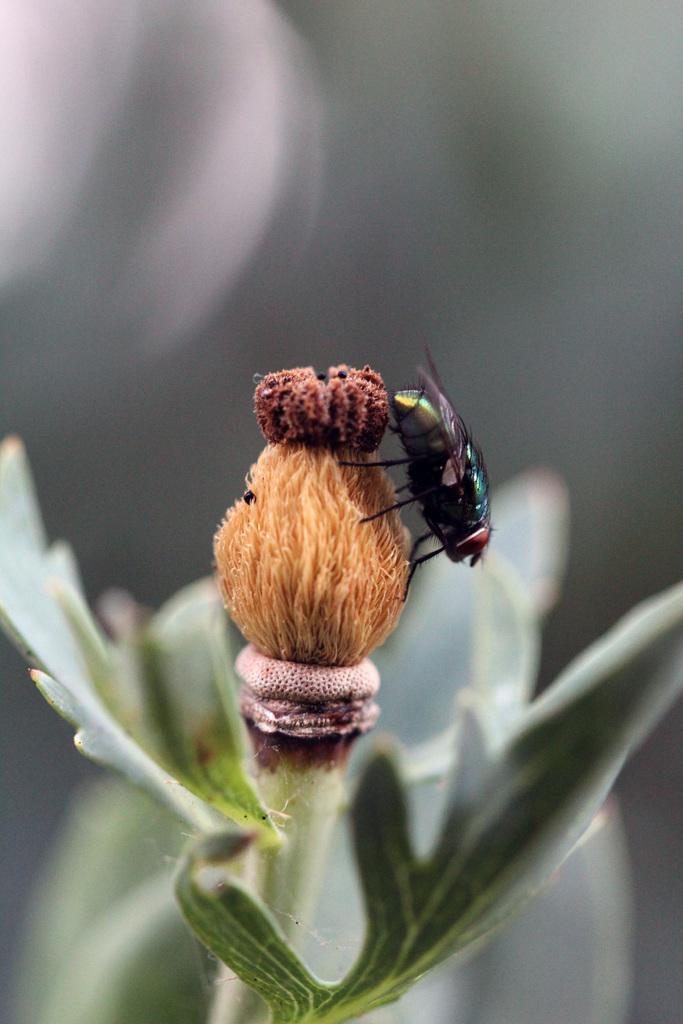What type of living organism is present in the image? There is a plant in the image. Can you describe any specific features of the plant? The plant has a leaf and a flower bud. Are there any other creatures visible in the image? Yes, there is a house fly in the image. What is a notable characteristic of the house fly? The house fly has wings. What type of drink is the plant holding in the image? There is no drink present in the image; the plant is not holding anything. Can you tell me how many pets are visible in the image? There are no pets visible in the image; only a plant and a house fly are present. 